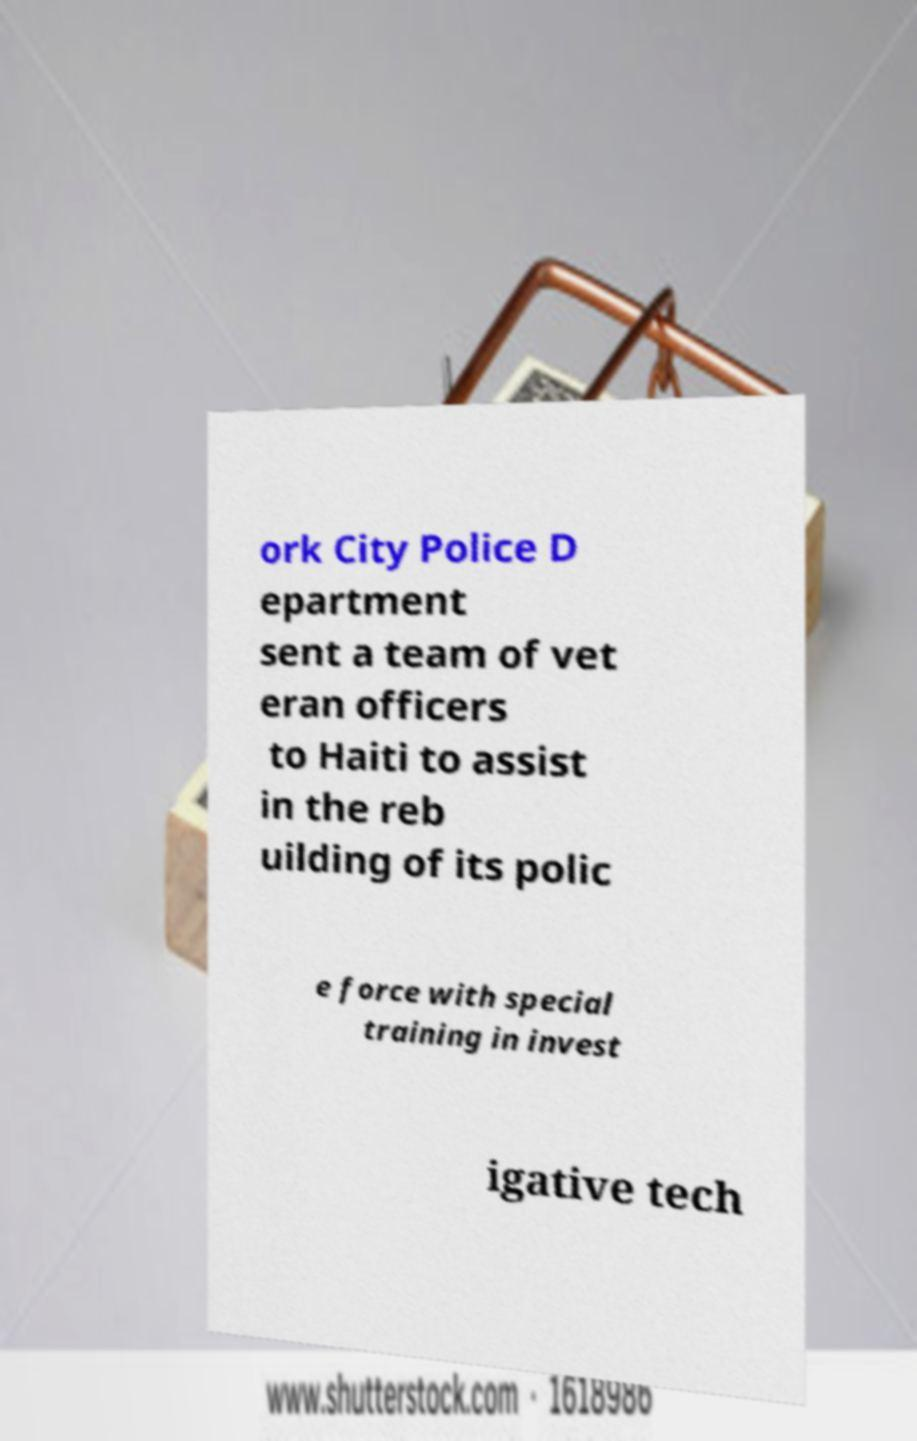Could you extract and type out the text from this image? ork City Police D epartment sent a team of vet eran officers to Haiti to assist in the reb uilding of its polic e force with special training in invest igative tech 